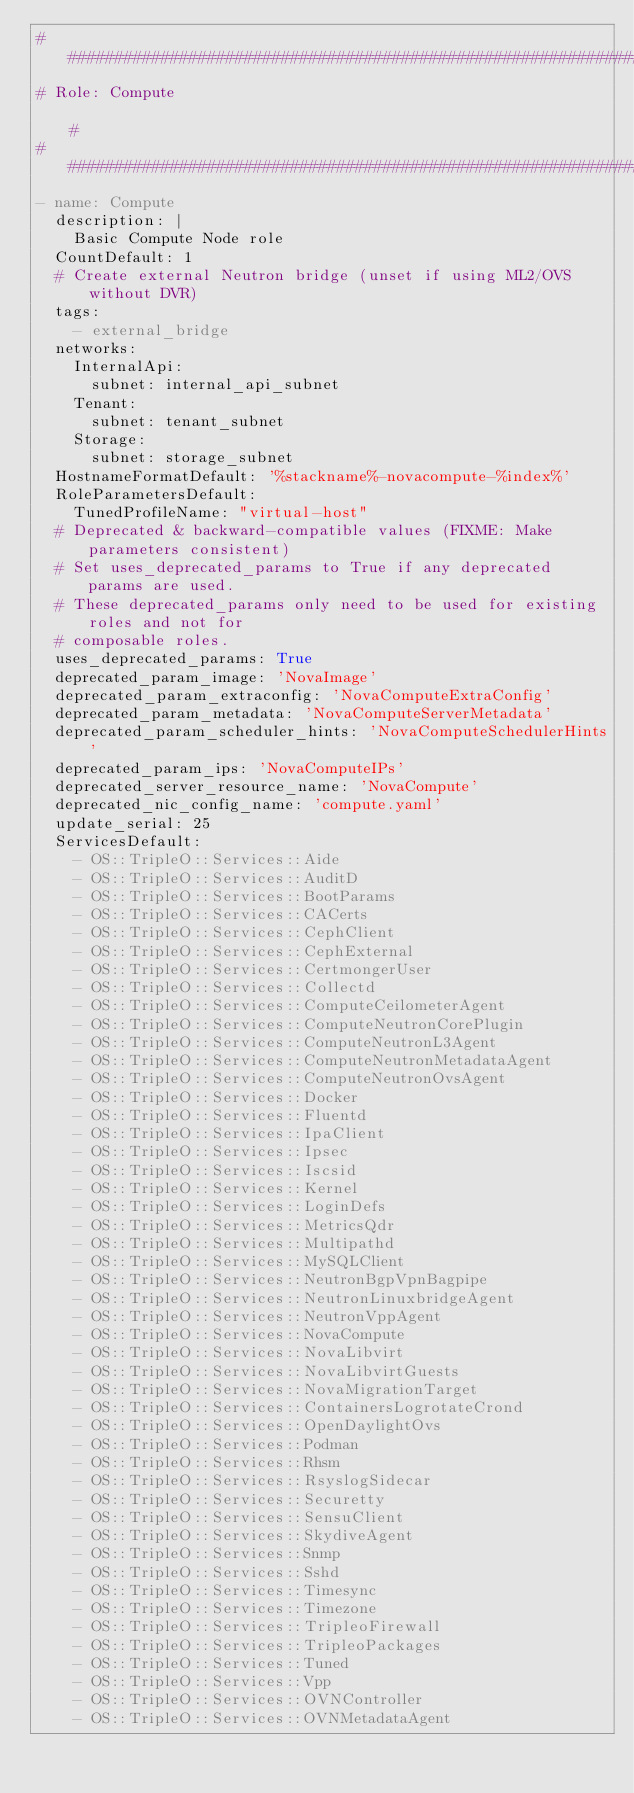Convert code to text. <code><loc_0><loc_0><loc_500><loc_500><_YAML_>###############################################################################
# Role: Compute                                                               #
###############################################################################
- name: Compute
  description: |
    Basic Compute Node role
  CountDefault: 1
  # Create external Neutron bridge (unset if using ML2/OVS without DVR)
  tags:
    - external_bridge
  networks:
    InternalApi:
      subnet: internal_api_subnet
    Tenant:
      subnet: tenant_subnet
    Storage:
      subnet: storage_subnet
  HostnameFormatDefault: '%stackname%-novacompute-%index%'
  RoleParametersDefault:
    TunedProfileName: "virtual-host"
  # Deprecated & backward-compatible values (FIXME: Make parameters consistent)
  # Set uses_deprecated_params to True if any deprecated params are used.
  # These deprecated_params only need to be used for existing roles and not for
  # composable roles.
  uses_deprecated_params: True
  deprecated_param_image: 'NovaImage'
  deprecated_param_extraconfig: 'NovaComputeExtraConfig'
  deprecated_param_metadata: 'NovaComputeServerMetadata'
  deprecated_param_scheduler_hints: 'NovaComputeSchedulerHints'
  deprecated_param_ips: 'NovaComputeIPs'
  deprecated_server_resource_name: 'NovaCompute'
  deprecated_nic_config_name: 'compute.yaml'
  update_serial: 25
  ServicesDefault:
    - OS::TripleO::Services::Aide
    - OS::TripleO::Services::AuditD
    - OS::TripleO::Services::BootParams
    - OS::TripleO::Services::CACerts
    - OS::TripleO::Services::CephClient
    - OS::TripleO::Services::CephExternal
    - OS::TripleO::Services::CertmongerUser
    - OS::TripleO::Services::Collectd
    - OS::TripleO::Services::ComputeCeilometerAgent
    - OS::TripleO::Services::ComputeNeutronCorePlugin
    - OS::TripleO::Services::ComputeNeutronL3Agent
    - OS::TripleO::Services::ComputeNeutronMetadataAgent
    - OS::TripleO::Services::ComputeNeutronOvsAgent
    - OS::TripleO::Services::Docker
    - OS::TripleO::Services::Fluentd
    - OS::TripleO::Services::IpaClient
    - OS::TripleO::Services::Ipsec
    - OS::TripleO::Services::Iscsid
    - OS::TripleO::Services::Kernel
    - OS::TripleO::Services::LoginDefs
    - OS::TripleO::Services::MetricsQdr
    - OS::TripleO::Services::Multipathd
    - OS::TripleO::Services::MySQLClient
    - OS::TripleO::Services::NeutronBgpVpnBagpipe
    - OS::TripleO::Services::NeutronLinuxbridgeAgent
    - OS::TripleO::Services::NeutronVppAgent
    - OS::TripleO::Services::NovaCompute
    - OS::TripleO::Services::NovaLibvirt
    - OS::TripleO::Services::NovaLibvirtGuests
    - OS::TripleO::Services::NovaMigrationTarget
    - OS::TripleO::Services::ContainersLogrotateCrond
    - OS::TripleO::Services::OpenDaylightOvs
    - OS::TripleO::Services::Podman
    - OS::TripleO::Services::Rhsm
    - OS::TripleO::Services::RsyslogSidecar
    - OS::TripleO::Services::Securetty
    - OS::TripleO::Services::SensuClient
    - OS::TripleO::Services::SkydiveAgent
    - OS::TripleO::Services::Snmp
    - OS::TripleO::Services::Sshd
    - OS::TripleO::Services::Timesync
    - OS::TripleO::Services::Timezone
    - OS::TripleO::Services::TripleoFirewall
    - OS::TripleO::Services::TripleoPackages
    - OS::TripleO::Services::Tuned
    - OS::TripleO::Services::Vpp
    - OS::TripleO::Services::OVNController
    - OS::TripleO::Services::OVNMetadataAgent
</code> 